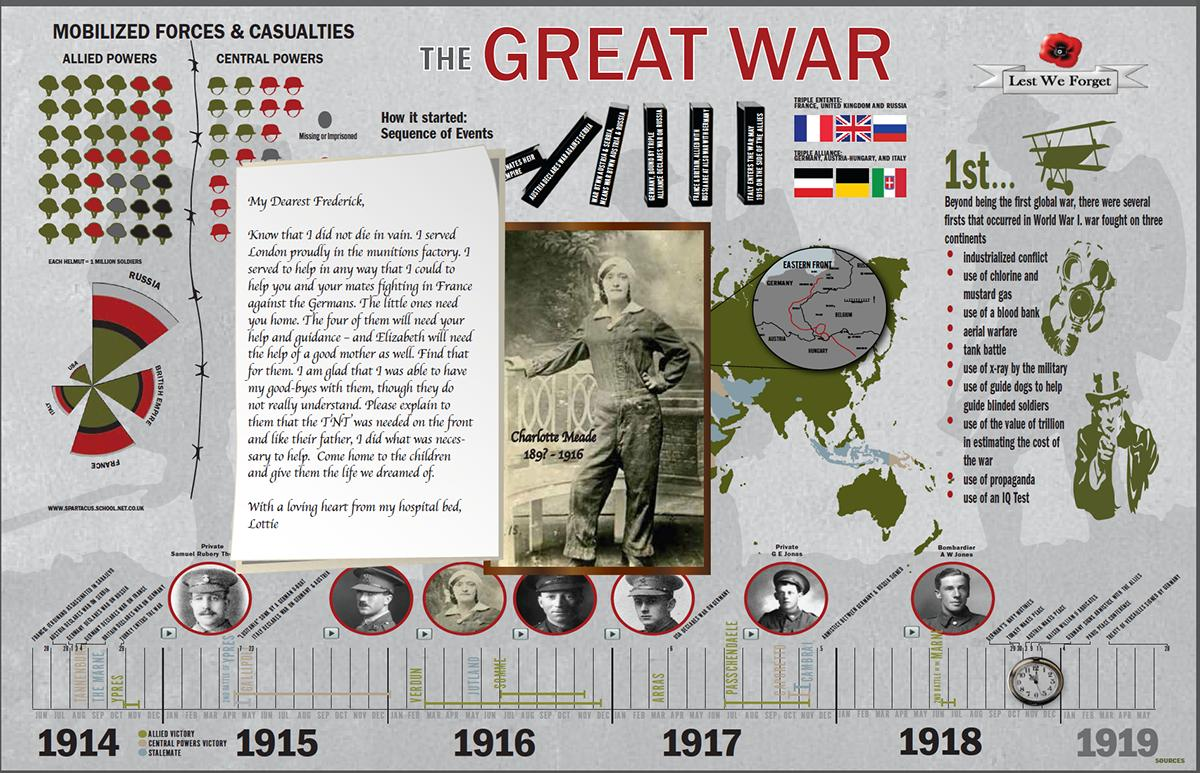Outline some significant characteristics in this image. The use of an IQ test was the last point mentioned among the firsts of World War 1. During the World War 1, chlorine and mustard gas were the second most commonly used chemical weapons, after gas shells filled with chlorine. 